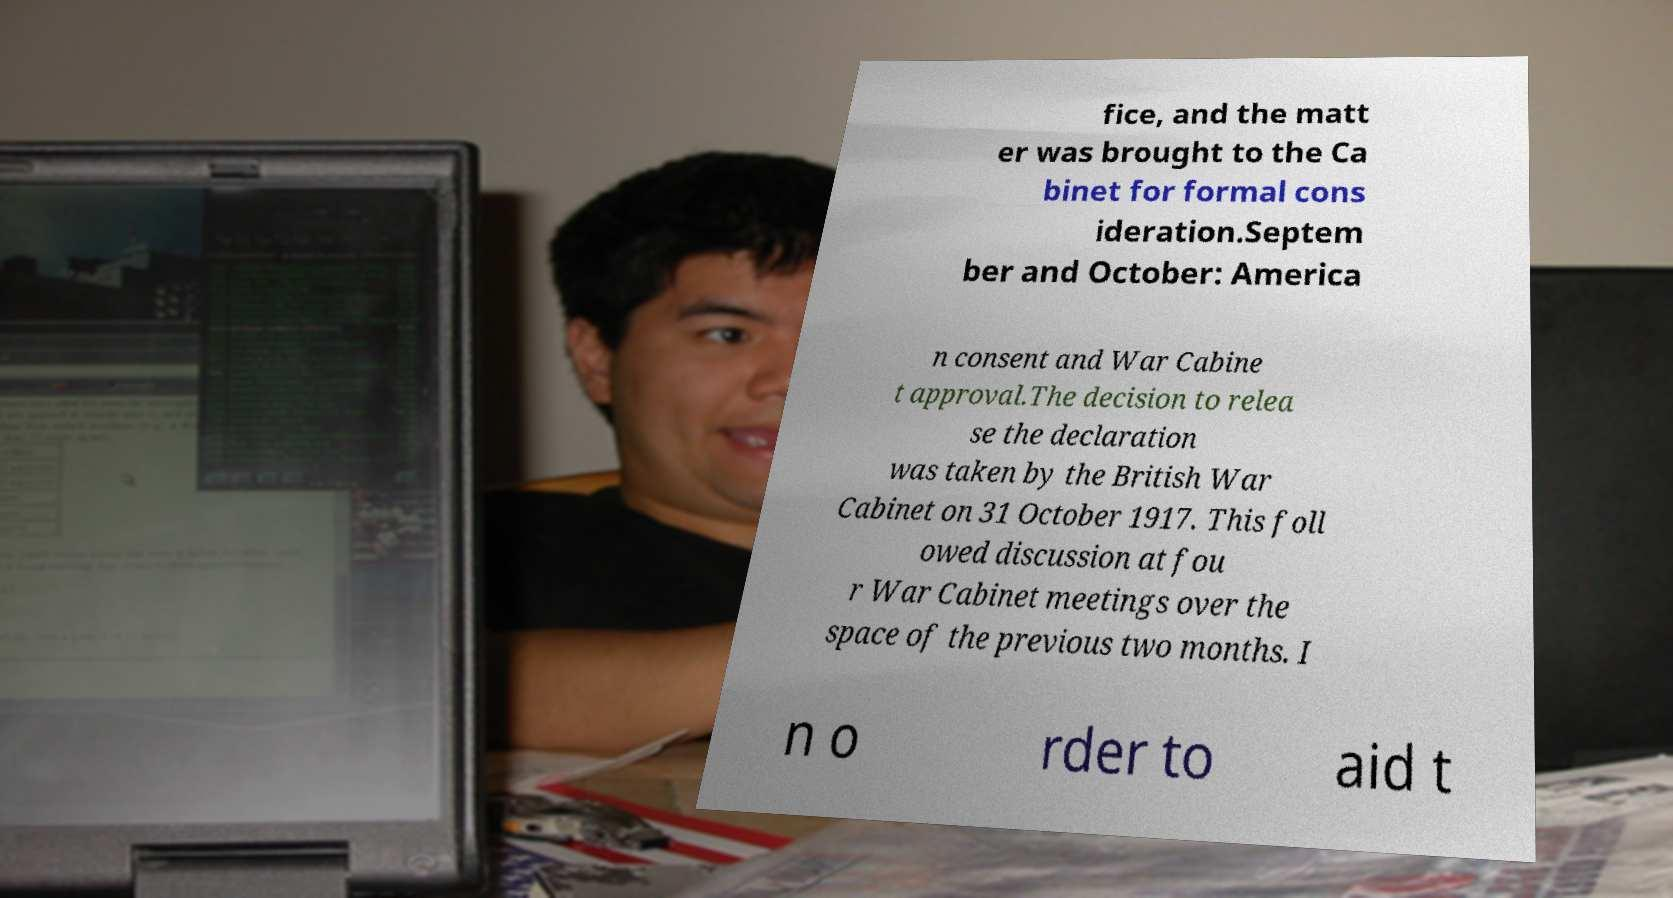For documentation purposes, I need the text within this image transcribed. Could you provide that? fice, and the matt er was brought to the Ca binet for formal cons ideration.Septem ber and October: America n consent and War Cabine t approval.The decision to relea se the declaration was taken by the British War Cabinet on 31 October 1917. This foll owed discussion at fou r War Cabinet meetings over the space of the previous two months. I n o rder to aid t 